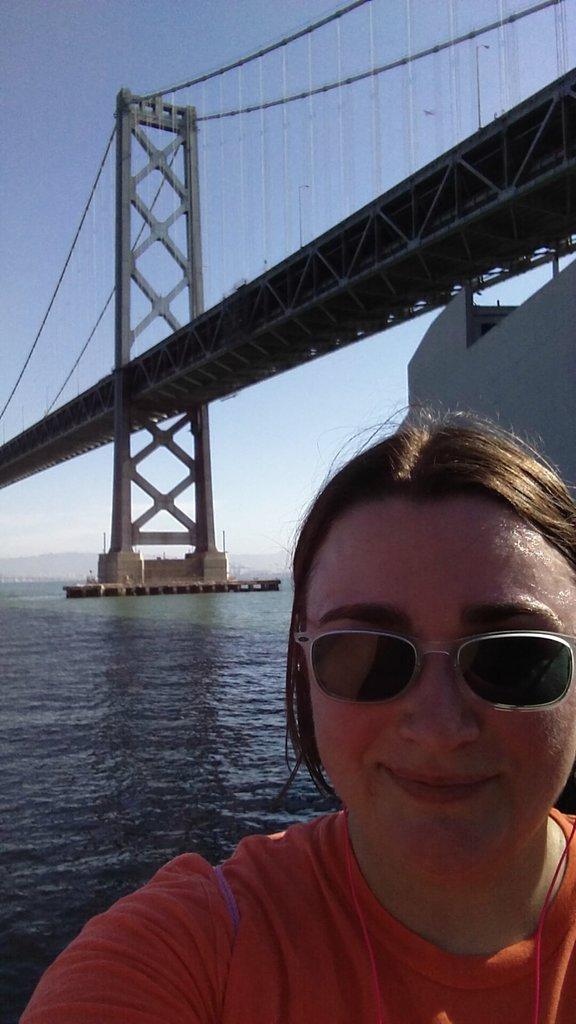Can you describe this image briefly? In the image we can see a person wearing a glasses,and at the top there is a bridge,and behind her there are some water and at the top we can see a sky. 